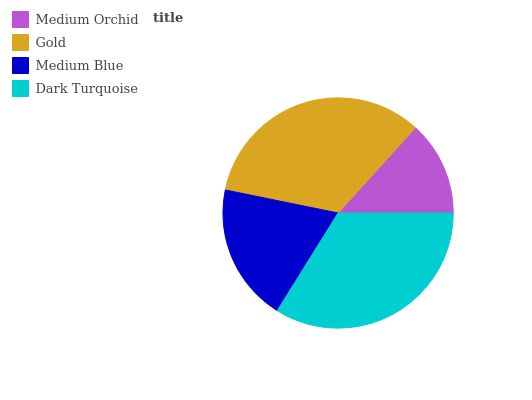Is Medium Orchid the minimum?
Answer yes or no. Yes. Is Dark Turquoise the maximum?
Answer yes or no. Yes. Is Gold the minimum?
Answer yes or no. No. Is Gold the maximum?
Answer yes or no. No. Is Gold greater than Medium Orchid?
Answer yes or no. Yes. Is Medium Orchid less than Gold?
Answer yes or no. Yes. Is Medium Orchid greater than Gold?
Answer yes or no. No. Is Gold less than Medium Orchid?
Answer yes or no. No. Is Gold the high median?
Answer yes or no. Yes. Is Medium Blue the low median?
Answer yes or no. Yes. Is Medium Orchid the high median?
Answer yes or no. No. Is Medium Orchid the low median?
Answer yes or no. No. 